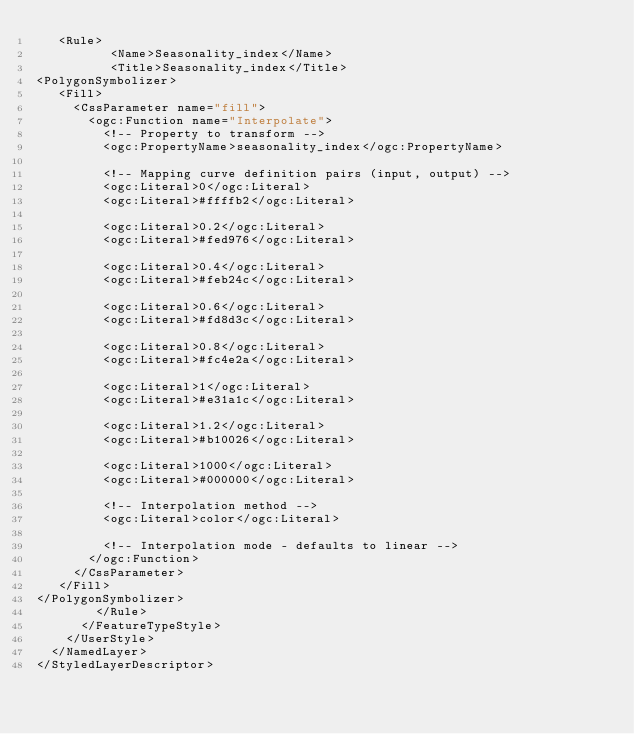<code> <loc_0><loc_0><loc_500><loc_500><_Scheme_>   <Rule>
          <Name>Seasonality_index</Name>
          <Title>Seasonality_index</Title>
<PolygonSymbolizer>
   <Fill>
     <CssParameter name="fill">
       <ogc:Function name="Interpolate">
         <!-- Property to transform -->
         <ogc:PropertyName>seasonality_index</ogc:PropertyName>

         <!-- Mapping curve definition pairs (input, output) -->
         <ogc:Literal>0</ogc:Literal>
         <ogc:Literal>#ffffb2</ogc:Literal>

         <ogc:Literal>0.2</ogc:Literal>
         <ogc:Literal>#fed976</ogc:Literal>

         <ogc:Literal>0.4</ogc:Literal>
         <ogc:Literal>#feb24c</ogc:Literal>

         <ogc:Literal>0.6</ogc:Literal>
         <ogc:Literal>#fd8d3c</ogc:Literal>

         <ogc:Literal>0.8</ogc:Literal>
         <ogc:Literal>#fc4e2a</ogc:Literal>
         
         <ogc:Literal>1</ogc:Literal>
         <ogc:Literal>#e31a1c</ogc:Literal>
         
         <ogc:Literal>1.2</ogc:Literal>
         <ogc:Literal>#b10026</ogc:Literal>
         
         <ogc:Literal>1000</ogc:Literal>
         <ogc:Literal>#000000</ogc:Literal>       

         <!-- Interpolation method -->
         <ogc:Literal>color</ogc:Literal>

         <!-- Interpolation mode - defaults to linear -->
       </ogc:Function>
     </CssParameter>
   </Fill>
</PolygonSymbolizer>
        </Rule>
      </FeatureTypeStyle>
    </UserStyle>
  </NamedLayer>
</StyledLayerDescriptor></code> 